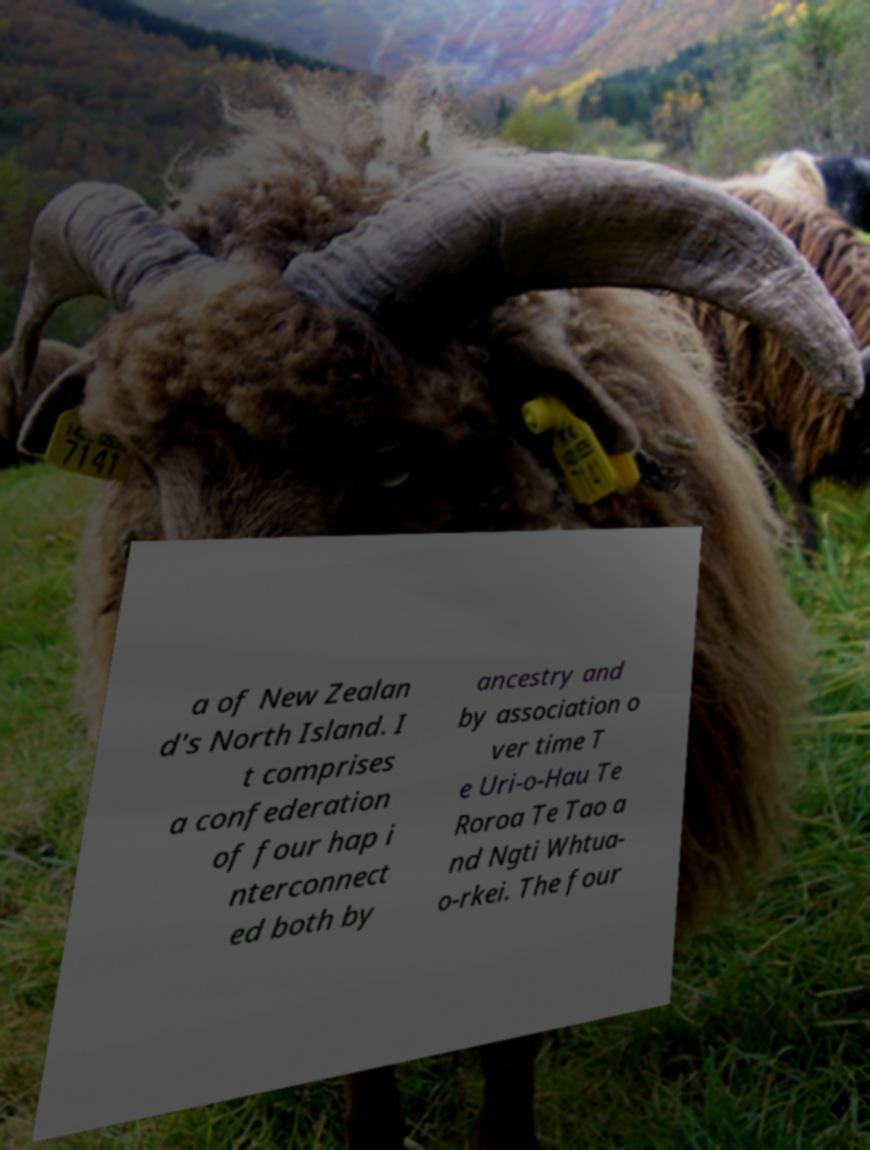Could you assist in decoding the text presented in this image and type it out clearly? a of New Zealan d's North Island. I t comprises a confederation of four hap i nterconnect ed both by ancestry and by association o ver time T e Uri-o-Hau Te Roroa Te Tao a nd Ngti Whtua- o-rkei. The four 